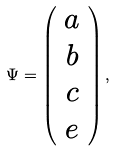Convert formula to latex. <formula><loc_0><loc_0><loc_500><loc_500>\Psi = \left ( \begin{array} { c } a \\ b \\ c \\ e \\ \end{array} \right ) ,</formula> 